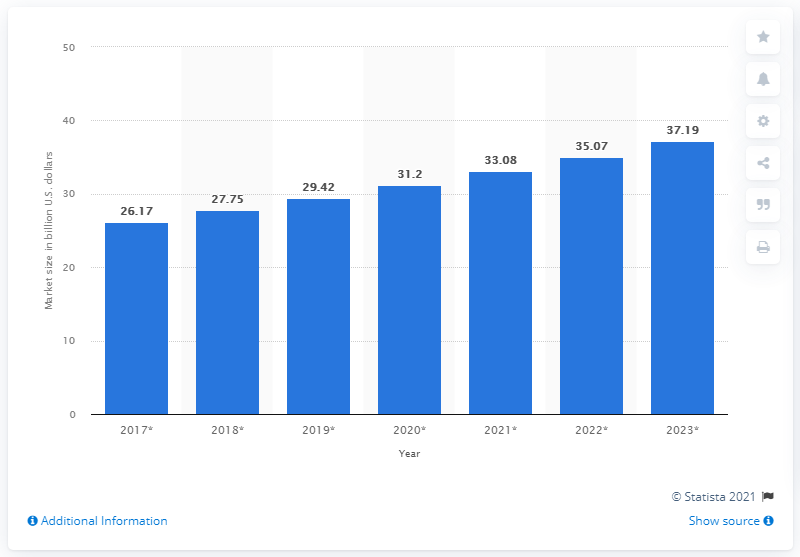Give some essential details in this illustration. In 2017, the global sexual wellness market was valued at approximately 26.17 billion dollars. The global sexual wellness market is expected to reach a forecasted value of 37.19 billion USD by 2023. 